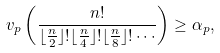<formula> <loc_0><loc_0><loc_500><loc_500>v _ { p } \left ( \frac { n ! } { \lfloor \frac { n } { 2 } \rfloor ! \lfloor \frac { n } { 4 } \rfloor ! \lfloor \frac { n } { 8 } \rfloor ! \cdots } \right ) \geq \alpha _ { p } ,</formula> 